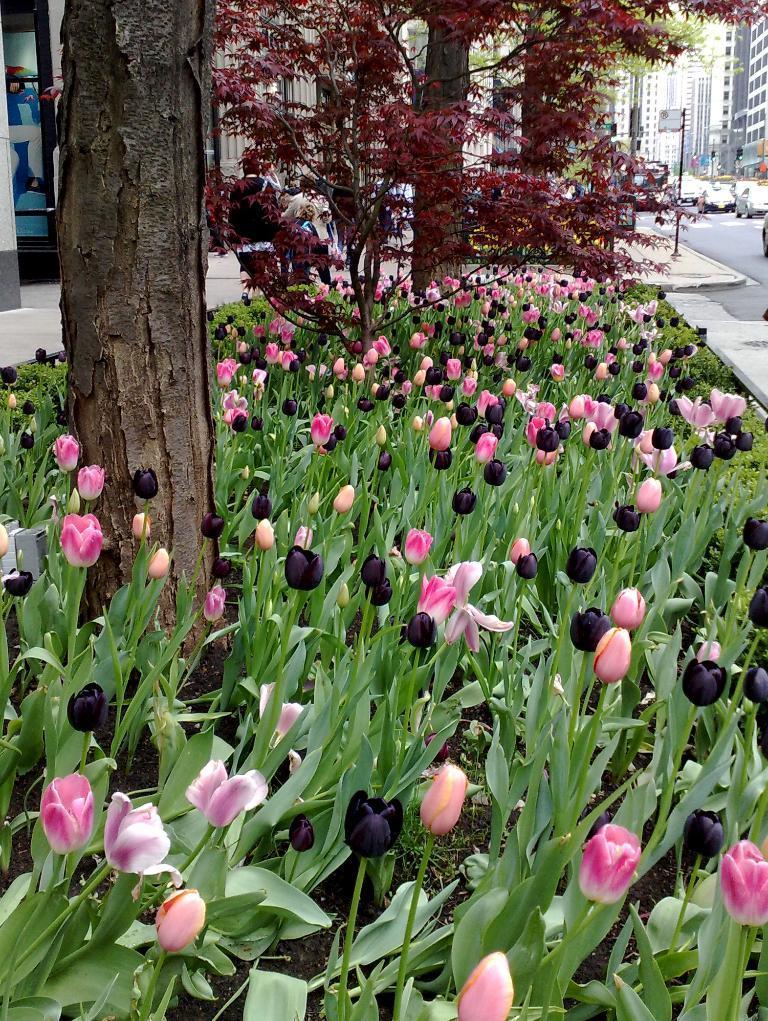How would you summarize this image in a sentence or two? In this image in front there are plants and flowers. There are trees. On the right side of the image there are cars on the road. There is a board. In the background of the image there are buildings. 